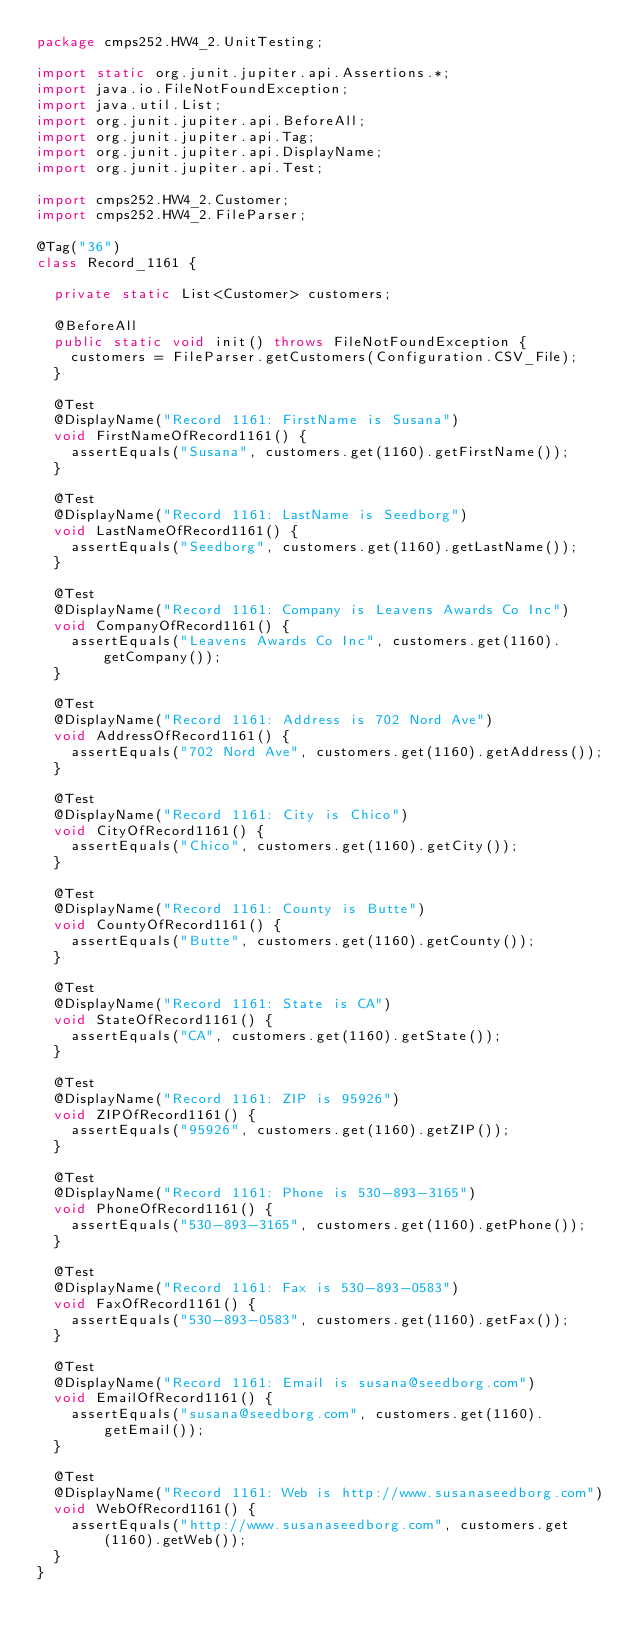<code> <loc_0><loc_0><loc_500><loc_500><_Java_>package cmps252.HW4_2.UnitTesting;

import static org.junit.jupiter.api.Assertions.*;
import java.io.FileNotFoundException;
import java.util.List;
import org.junit.jupiter.api.BeforeAll;
import org.junit.jupiter.api.Tag;
import org.junit.jupiter.api.DisplayName;
import org.junit.jupiter.api.Test;

import cmps252.HW4_2.Customer;
import cmps252.HW4_2.FileParser;

@Tag("36")
class Record_1161 {

	private static List<Customer> customers;

	@BeforeAll
	public static void init() throws FileNotFoundException {
		customers = FileParser.getCustomers(Configuration.CSV_File);
	}

	@Test
	@DisplayName("Record 1161: FirstName is Susana")
	void FirstNameOfRecord1161() {
		assertEquals("Susana", customers.get(1160).getFirstName());
	}

	@Test
	@DisplayName("Record 1161: LastName is Seedborg")
	void LastNameOfRecord1161() {
		assertEquals("Seedborg", customers.get(1160).getLastName());
	}

	@Test
	@DisplayName("Record 1161: Company is Leavens Awards Co Inc")
	void CompanyOfRecord1161() {
		assertEquals("Leavens Awards Co Inc", customers.get(1160).getCompany());
	}

	@Test
	@DisplayName("Record 1161: Address is 702 Nord Ave")
	void AddressOfRecord1161() {
		assertEquals("702 Nord Ave", customers.get(1160).getAddress());
	}

	@Test
	@DisplayName("Record 1161: City is Chico")
	void CityOfRecord1161() {
		assertEquals("Chico", customers.get(1160).getCity());
	}

	@Test
	@DisplayName("Record 1161: County is Butte")
	void CountyOfRecord1161() {
		assertEquals("Butte", customers.get(1160).getCounty());
	}

	@Test
	@DisplayName("Record 1161: State is CA")
	void StateOfRecord1161() {
		assertEquals("CA", customers.get(1160).getState());
	}

	@Test
	@DisplayName("Record 1161: ZIP is 95926")
	void ZIPOfRecord1161() {
		assertEquals("95926", customers.get(1160).getZIP());
	}

	@Test
	@DisplayName("Record 1161: Phone is 530-893-3165")
	void PhoneOfRecord1161() {
		assertEquals("530-893-3165", customers.get(1160).getPhone());
	}

	@Test
	@DisplayName("Record 1161: Fax is 530-893-0583")
	void FaxOfRecord1161() {
		assertEquals("530-893-0583", customers.get(1160).getFax());
	}

	@Test
	@DisplayName("Record 1161: Email is susana@seedborg.com")
	void EmailOfRecord1161() {
		assertEquals("susana@seedborg.com", customers.get(1160).getEmail());
	}

	@Test
	@DisplayName("Record 1161: Web is http://www.susanaseedborg.com")
	void WebOfRecord1161() {
		assertEquals("http://www.susanaseedborg.com", customers.get(1160).getWeb());
	}
}
</code> 